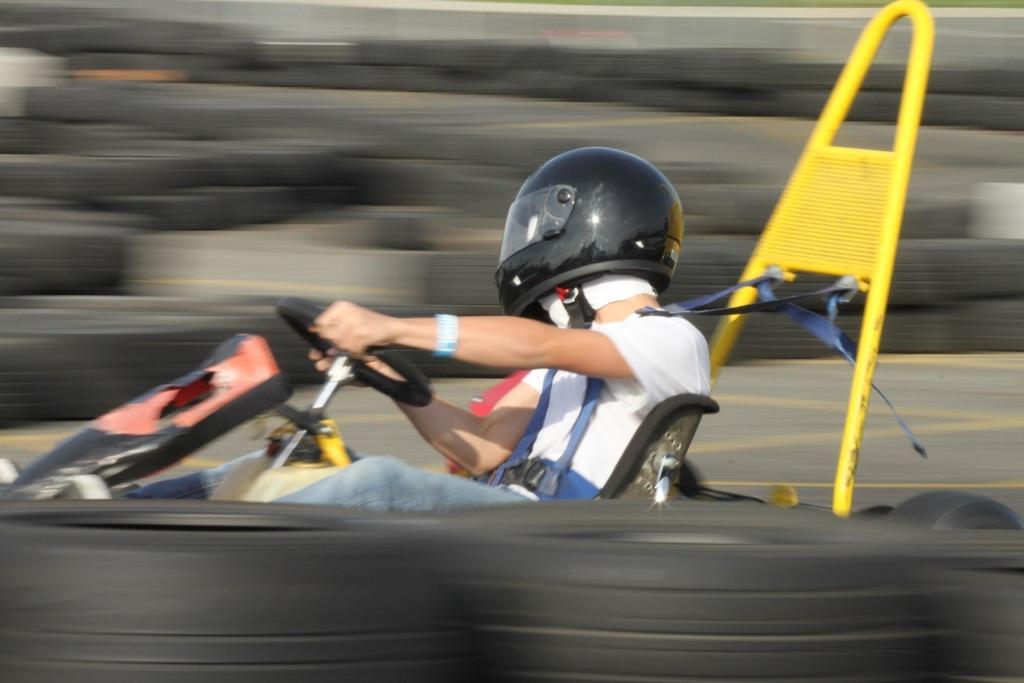Could you give a brief overview of what you see in this image? In the center of the picture there is a person driving a go kart. The edges of the picture are blurred. 